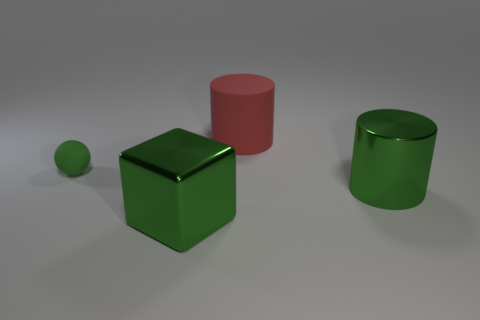Add 3 red cylinders. How many objects exist? 7 Subtract all balls. How many objects are left? 3 Add 4 big red things. How many big red things are left? 5 Add 2 tiny cyan metallic balls. How many tiny cyan metallic balls exist? 2 Subtract 1 green cylinders. How many objects are left? 3 Subtract all tiny blue matte objects. Subtract all tiny matte things. How many objects are left? 3 